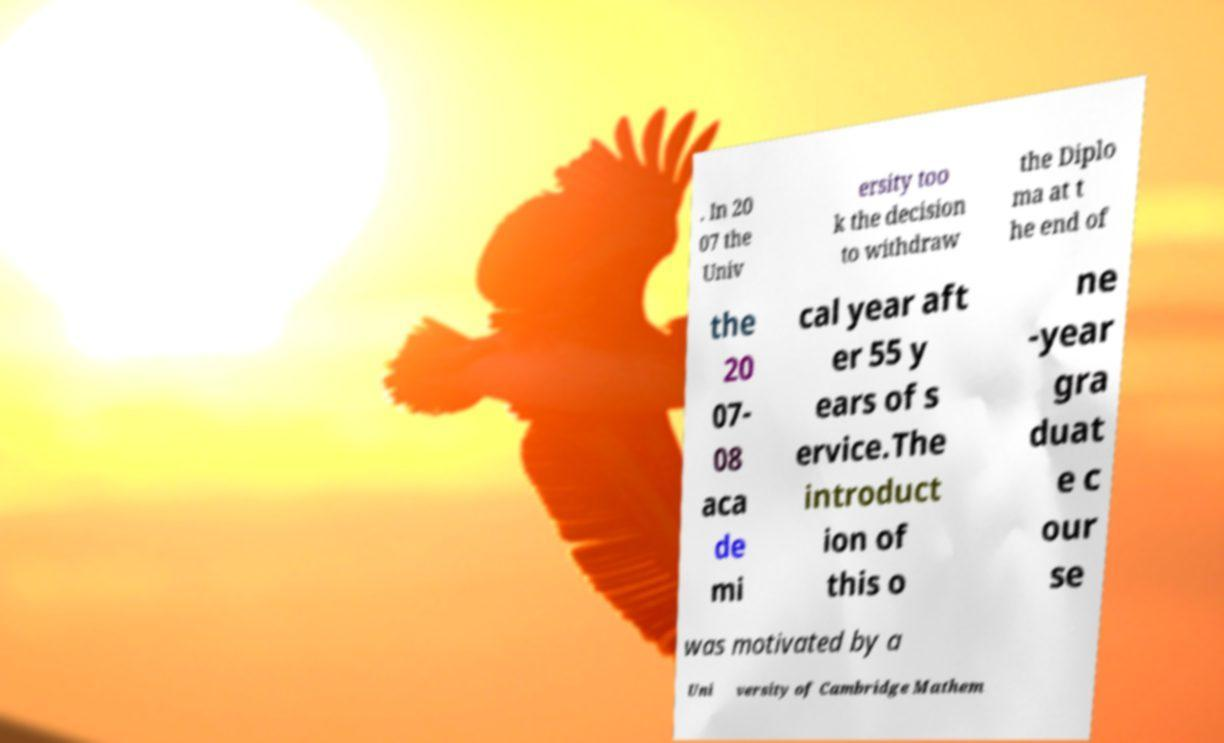I need the written content from this picture converted into text. Can you do that? . In 20 07 the Univ ersity too k the decision to withdraw the Diplo ma at t he end of the 20 07- 08 aca de mi cal year aft er 55 y ears of s ervice.The introduct ion of this o ne -year gra duat e c our se was motivated by a Uni versity of Cambridge Mathem 